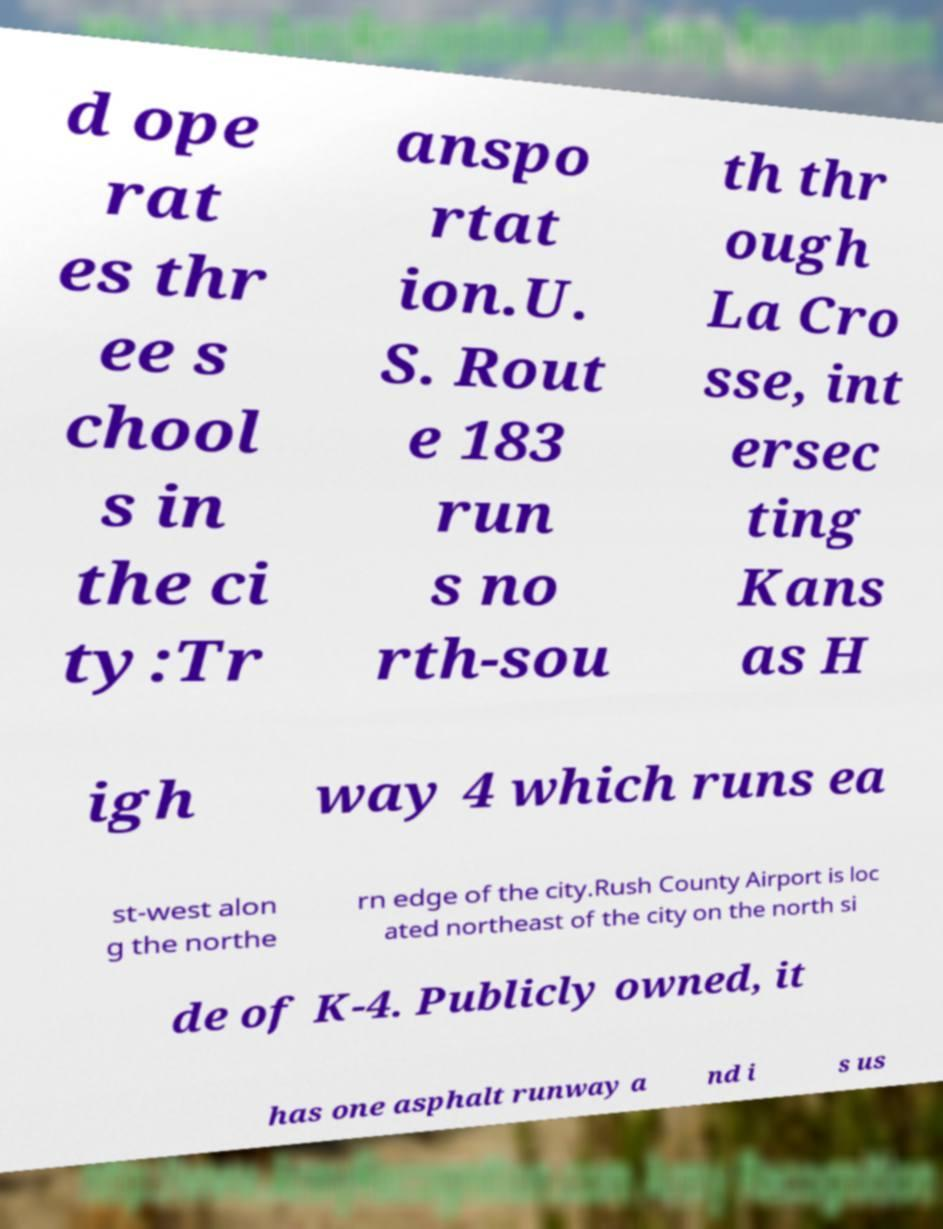Can you accurately transcribe the text from the provided image for me? d ope rat es thr ee s chool s in the ci ty:Tr anspo rtat ion.U. S. Rout e 183 run s no rth-sou th thr ough La Cro sse, int ersec ting Kans as H igh way 4 which runs ea st-west alon g the northe rn edge of the city.Rush County Airport is loc ated northeast of the city on the north si de of K-4. Publicly owned, it has one asphalt runway a nd i s us 